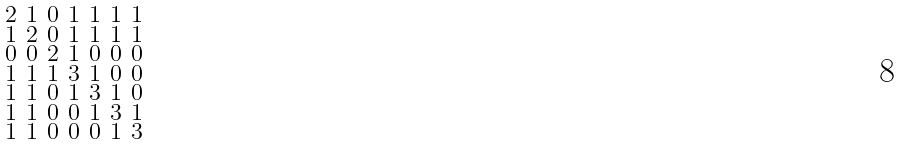<formula> <loc_0><loc_0><loc_500><loc_500>\begin{smallmatrix} 2 & 1 & 0 & 1 & 1 & 1 & 1 \\ 1 & 2 & 0 & 1 & 1 & 1 & 1 \\ 0 & 0 & 2 & 1 & 0 & 0 & 0 \\ 1 & 1 & 1 & 3 & 1 & 0 & 0 \\ 1 & 1 & 0 & 1 & 3 & 1 & 0 \\ 1 & 1 & 0 & 0 & 1 & 3 & 1 \\ 1 & 1 & 0 & 0 & 0 & 1 & 3 \end{smallmatrix}</formula> 